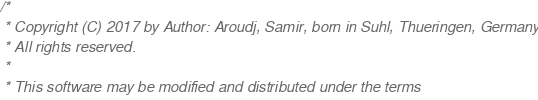<code> <loc_0><loc_0><loc_500><loc_500><_C++_>/*
 * Copyright (C) 2017 by Author: Aroudj, Samir, born in Suhl, Thueringen, Germany
 * All rights reserved.
 *
 * This software may be modified and distributed under the terms</code> 